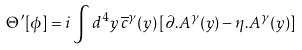Convert formula to latex. <formula><loc_0><loc_0><loc_500><loc_500>\Theta ^ { \prime } [ \phi ] = i \int d ^ { 4 } y \, \overline { c } ^ { \gamma } ( y ) \left [ \partial . A ^ { \gamma } ( y ) - \eta . A ^ { \gamma } ( y ) \right ]</formula> 